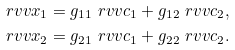<formula> <loc_0><loc_0><loc_500><loc_500>\ r v v { x } _ { 1 } & = g _ { 1 1 } \ r v v { c } _ { 1 } + g _ { 1 2 } \ r v v { c } _ { 2 } , \\ \ r v v { x } _ { 2 } & = g _ { 2 1 } \ r v v { c } _ { 1 } + g _ { 2 2 } \ r v v { c } _ { 2 } .</formula> 